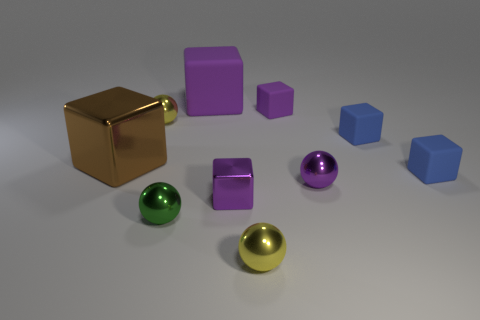Subtract all brown cylinders. How many yellow spheres are left? 2 Subtract all small purple metal balls. How many balls are left? 3 Subtract 2 balls. How many balls are left? 2 Subtract all blue cubes. How many cubes are left? 4 Subtract all blue spheres. Subtract all blue cubes. How many spheres are left? 4 Subtract all cubes. How many objects are left? 4 Add 4 purple blocks. How many purple blocks are left? 7 Add 5 small red blocks. How many small red blocks exist? 5 Subtract 1 purple balls. How many objects are left? 9 Subtract all large yellow rubber blocks. Subtract all big purple matte objects. How many objects are left? 9 